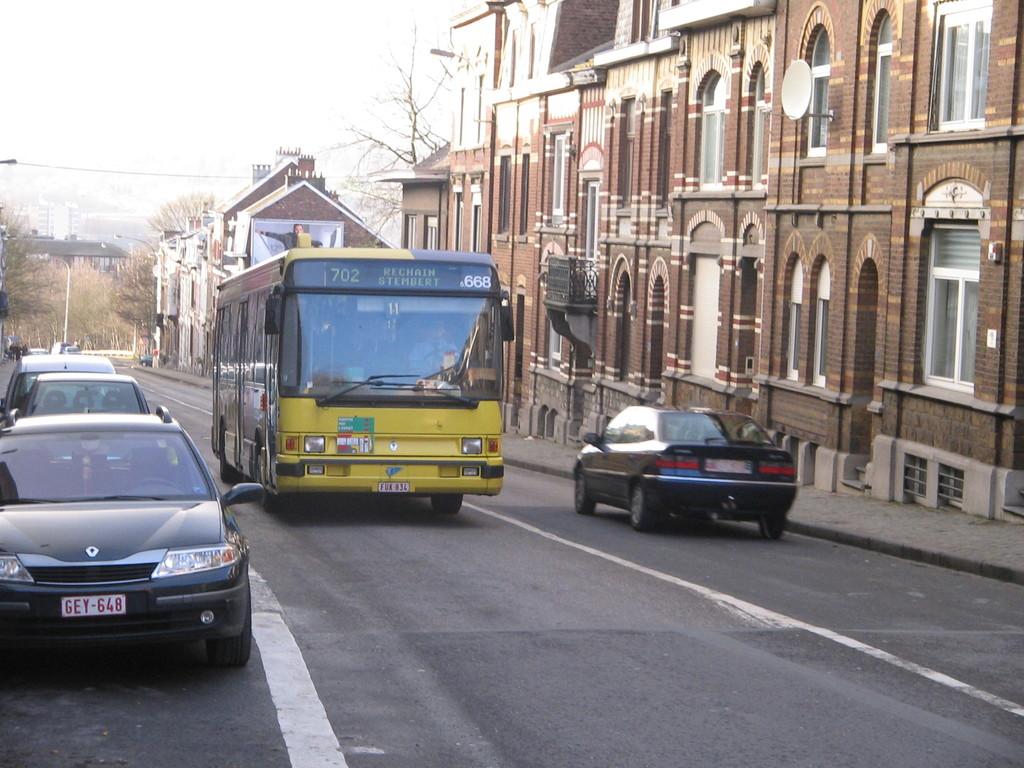What is the route the bus is taking?
Provide a succinct answer. Rechain stembert. What is the route number of the bus?
Your answer should be very brief. 702. 